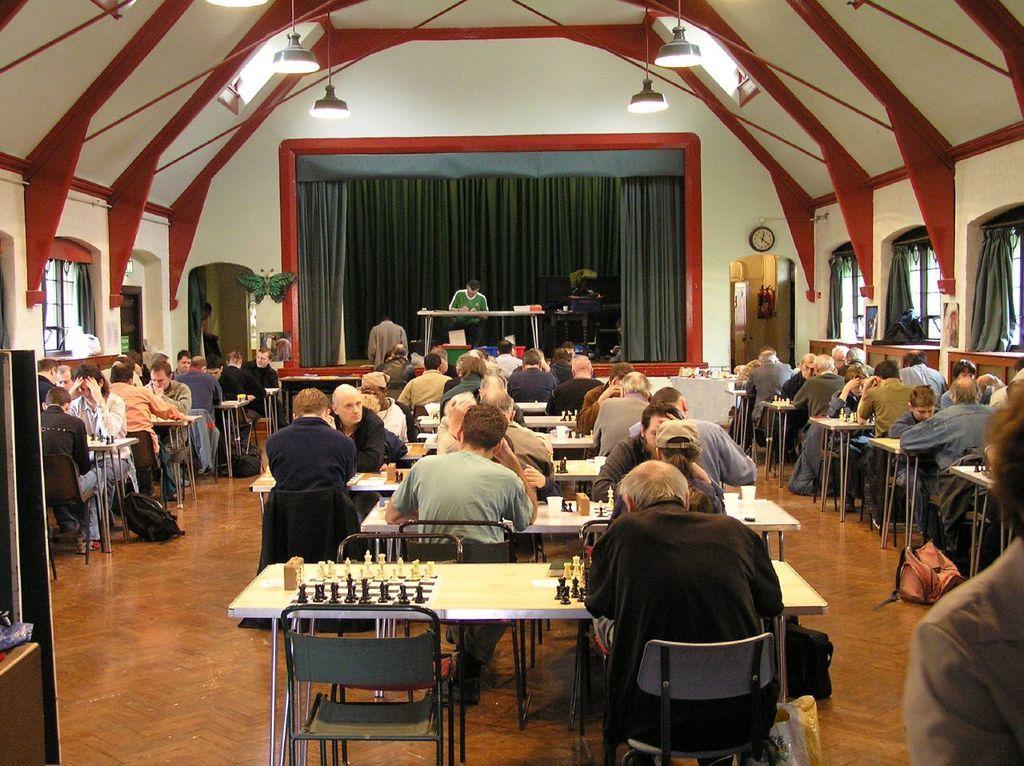Please provide a concise description of this image. there is a big hall there are many people sitting on benches and they are playing the chess and room has many windows and all are playing on the chess game in the room there are so many chairs and tables and the roof was painted by red and white colored and it has many lights. 